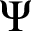Convert formula to latex. <formula><loc_0><loc_0><loc_500><loc_500>\Psi</formula> 